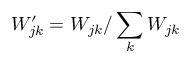<formula> <loc_0><loc_0><loc_500><loc_500>W _ { j k } ^ { \prime } = W _ { j k } / \sum _ { k } W _ { j k }</formula> 